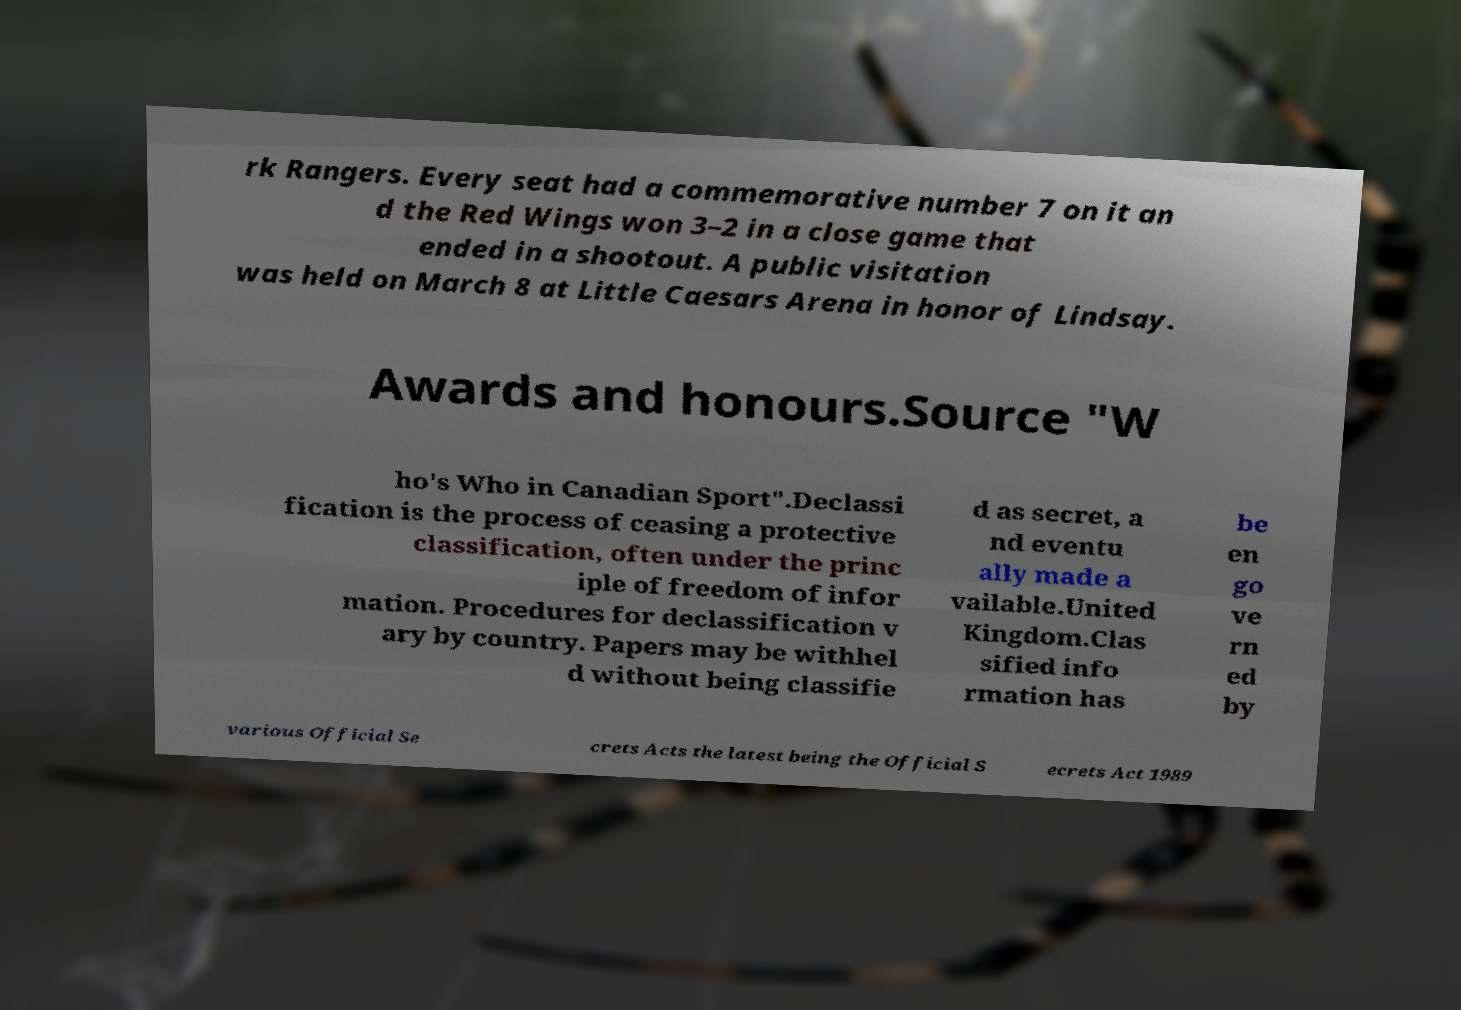Can you read and provide the text displayed in the image?This photo seems to have some interesting text. Can you extract and type it out for me? rk Rangers. Every seat had a commemorative number 7 on it an d the Red Wings won 3–2 in a close game that ended in a shootout. A public visitation was held on March 8 at Little Caesars Arena in honor of Lindsay. Awards and honours.Source "W ho's Who in Canadian Sport".Declassi fication is the process of ceasing a protective classification, often under the princ iple of freedom of infor mation. Procedures for declassification v ary by country. Papers may be withhel d without being classifie d as secret, a nd eventu ally made a vailable.United Kingdom.Clas sified info rmation has be en go ve rn ed by various Official Se crets Acts the latest being the Official S ecrets Act 1989 